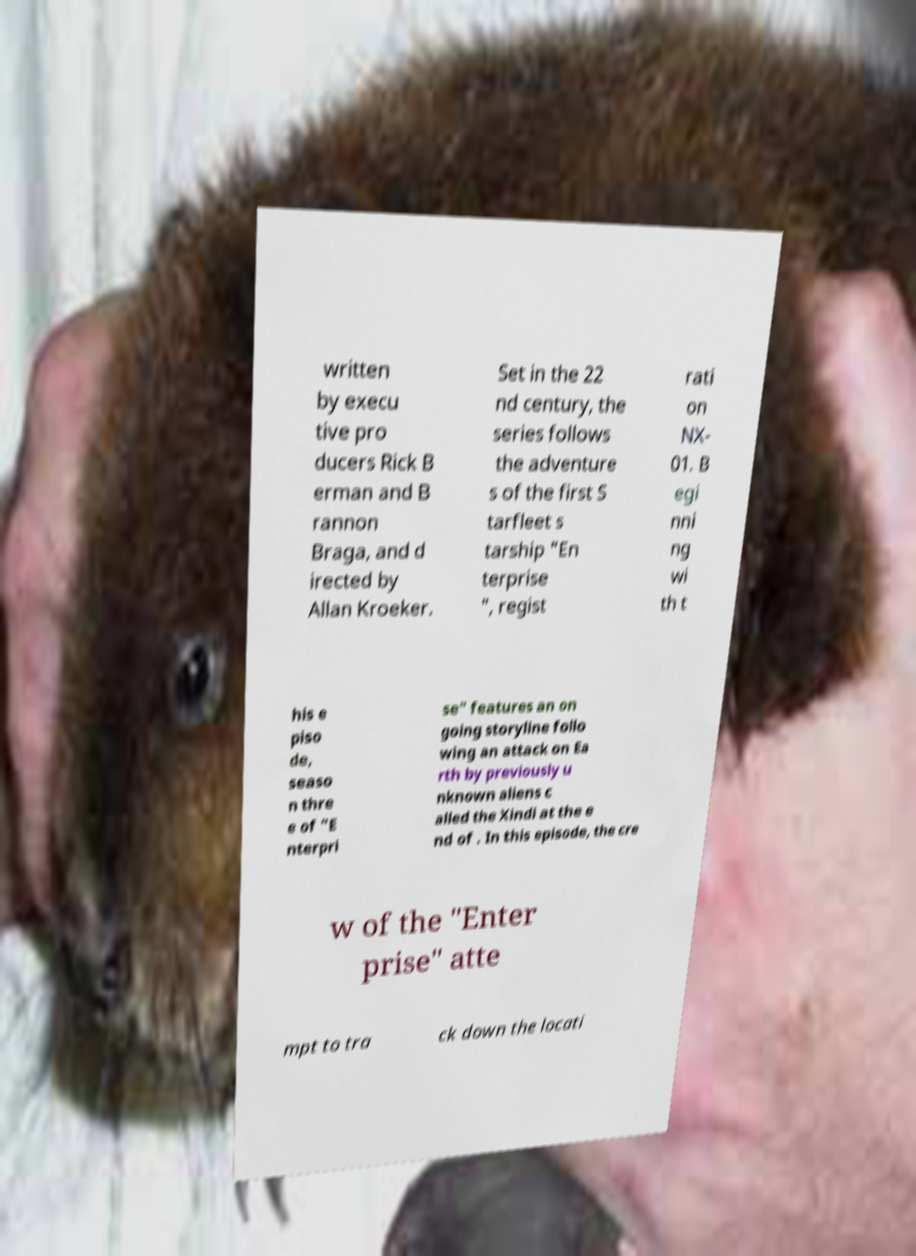Could you extract and type out the text from this image? written by execu tive pro ducers Rick B erman and B rannon Braga, and d irected by Allan Kroeker. Set in the 22 nd century, the series follows the adventure s of the first S tarfleet s tarship "En terprise ", regist rati on NX- 01. B egi nni ng wi th t his e piso de, seaso n thre e of "E nterpri se" features an on going storyline follo wing an attack on Ea rth by previously u nknown aliens c alled the Xindi at the e nd of . In this episode, the cre w of the "Enter prise" atte mpt to tra ck down the locati 